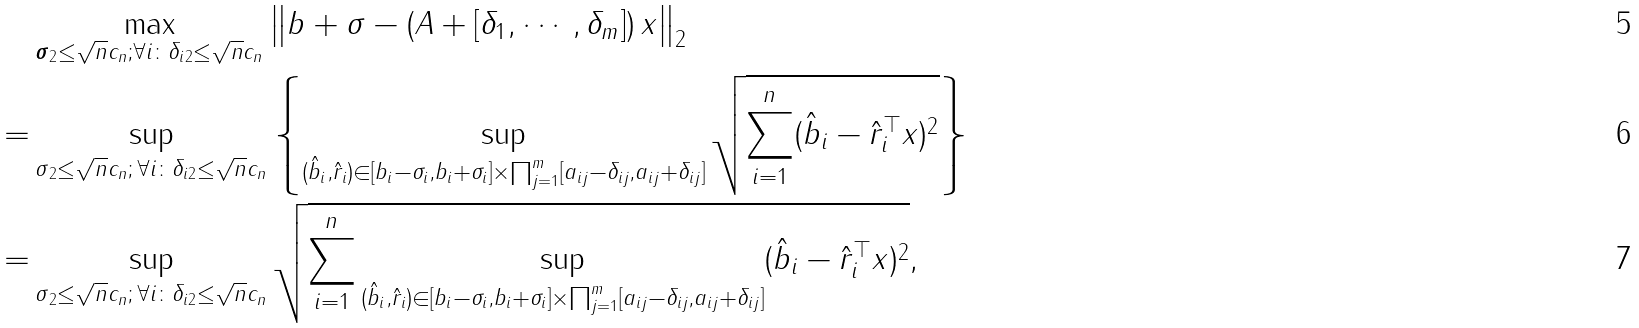<formula> <loc_0><loc_0><loc_500><loc_500>& \max _ { \| \boldsymbol \sigma \| _ { 2 } \leq \sqrt { n } c _ { n } ; \forall i \colon \| \delta _ { i } \| _ { 2 } \leq \sqrt { n } c _ { n } } \left \| b + \sigma - \left ( A + [ \delta _ { 1 } , \cdots , \delta _ { m } ] \right ) x \right \| _ { 2 } \\ = & \sup _ { \| \sigma \| _ { 2 } \leq \sqrt { n } c _ { n } ; \, \forall i \colon \| \delta _ { i } \| _ { 2 } \leq \sqrt { n } c _ { n } } \left \{ \sup _ { ( \hat { b } _ { i } , \hat { r } _ { i } ) \in [ b _ { i } - \sigma _ { i } , b _ { i } + \sigma _ { i } ] \times \prod _ { j = 1 } ^ { m } [ a _ { i j } - \delta _ { i j } , a _ { i j } + \delta _ { i j } ] } \sqrt { \sum _ { i = 1 } ^ { n } ( \hat { b } _ { i } - \hat { r } _ { i } ^ { \top } x ) ^ { 2 } } \right \} \\ = & \sup _ { \| \sigma \| _ { 2 } \leq \sqrt { n } c _ { n } ; \, \forall i \colon \| \delta _ { i } \| _ { 2 } \leq \sqrt { n } c _ { n } } \sqrt { \sum _ { i = 1 } ^ { n } \sup _ { ( \hat { b } _ { i } , \hat { r } _ { i } ) \in [ b _ { i } - \sigma _ { i } , b _ { i } + \sigma _ { i } ] \times \prod _ { j = 1 } ^ { m } [ a _ { i j } - \delta _ { i j } , a _ { i j } + \delta _ { i j } ] } ( \hat { b } _ { i } - \hat { r } _ { i } ^ { \top } x ) ^ { 2 } } ,</formula> 